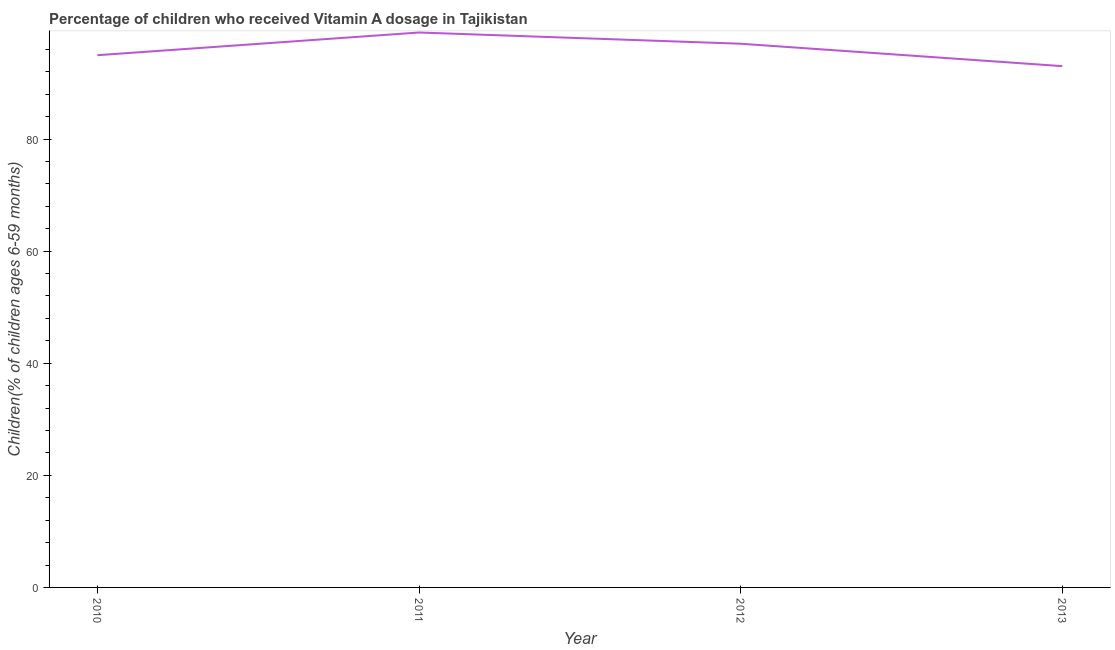What is the vitamin a supplementation coverage rate in 2013?
Your answer should be compact. 93. Across all years, what is the maximum vitamin a supplementation coverage rate?
Keep it short and to the point. 99. Across all years, what is the minimum vitamin a supplementation coverage rate?
Provide a short and direct response. 93. In which year was the vitamin a supplementation coverage rate minimum?
Offer a very short reply. 2013. What is the sum of the vitamin a supplementation coverage rate?
Ensure brevity in your answer.  383.95. What is the average vitamin a supplementation coverage rate per year?
Keep it short and to the point. 95.99. What is the median vitamin a supplementation coverage rate?
Ensure brevity in your answer.  95.97. In how many years, is the vitamin a supplementation coverage rate greater than 8 %?
Make the answer very short. 4. What is the ratio of the vitamin a supplementation coverage rate in 2012 to that in 2013?
Keep it short and to the point. 1.04. Is the vitamin a supplementation coverage rate in 2011 less than that in 2013?
Make the answer very short. No. What is the difference between the highest and the second highest vitamin a supplementation coverage rate?
Your answer should be very brief. 2. What is the difference between the highest and the lowest vitamin a supplementation coverage rate?
Provide a succinct answer. 6. Does the vitamin a supplementation coverage rate monotonically increase over the years?
Give a very brief answer. No. How many years are there in the graph?
Provide a succinct answer. 4. What is the title of the graph?
Provide a short and direct response. Percentage of children who received Vitamin A dosage in Tajikistan. What is the label or title of the Y-axis?
Your answer should be compact. Children(% of children ages 6-59 months). What is the Children(% of children ages 6-59 months) in 2010?
Make the answer very short. 94.95. What is the Children(% of children ages 6-59 months) in 2012?
Ensure brevity in your answer.  97. What is the Children(% of children ages 6-59 months) in 2013?
Offer a very short reply. 93. What is the difference between the Children(% of children ages 6-59 months) in 2010 and 2011?
Make the answer very short. -4.05. What is the difference between the Children(% of children ages 6-59 months) in 2010 and 2012?
Your answer should be compact. -2.05. What is the difference between the Children(% of children ages 6-59 months) in 2010 and 2013?
Make the answer very short. 1.95. What is the difference between the Children(% of children ages 6-59 months) in 2011 and 2012?
Offer a very short reply. 2. What is the difference between the Children(% of children ages 6-59 months) in 2011 and 2013?
Your answer should be compact. 6. What is the difference between the Children(% of children ages 6-59 months) in 2012 and 2013?
Provide a succinct answer. 4. What is the ratio of the Children(% of children ages 6-59 months) in 2010 to that in 2012?
Offer a very short reply. 0.98. What is the ratio of the Children(% of children ages 6-59 months) in 2010 to that in 2013?
Your response must be concise. 1.02. What is the ratio of the Children(% of children ages 6-59 months) in 2011 to that in 2012?
Your answer should be very brief. 1.02. What is the ratio of the Children(% of children ages 6-59 months) in 2011 to that in 2013?
Offer a very short reply. 1.06. What is the ratio of the Children(% of children ages 6-59 months) in 2012 to that in 2013?
Keep it short and to the point. 1.04. 